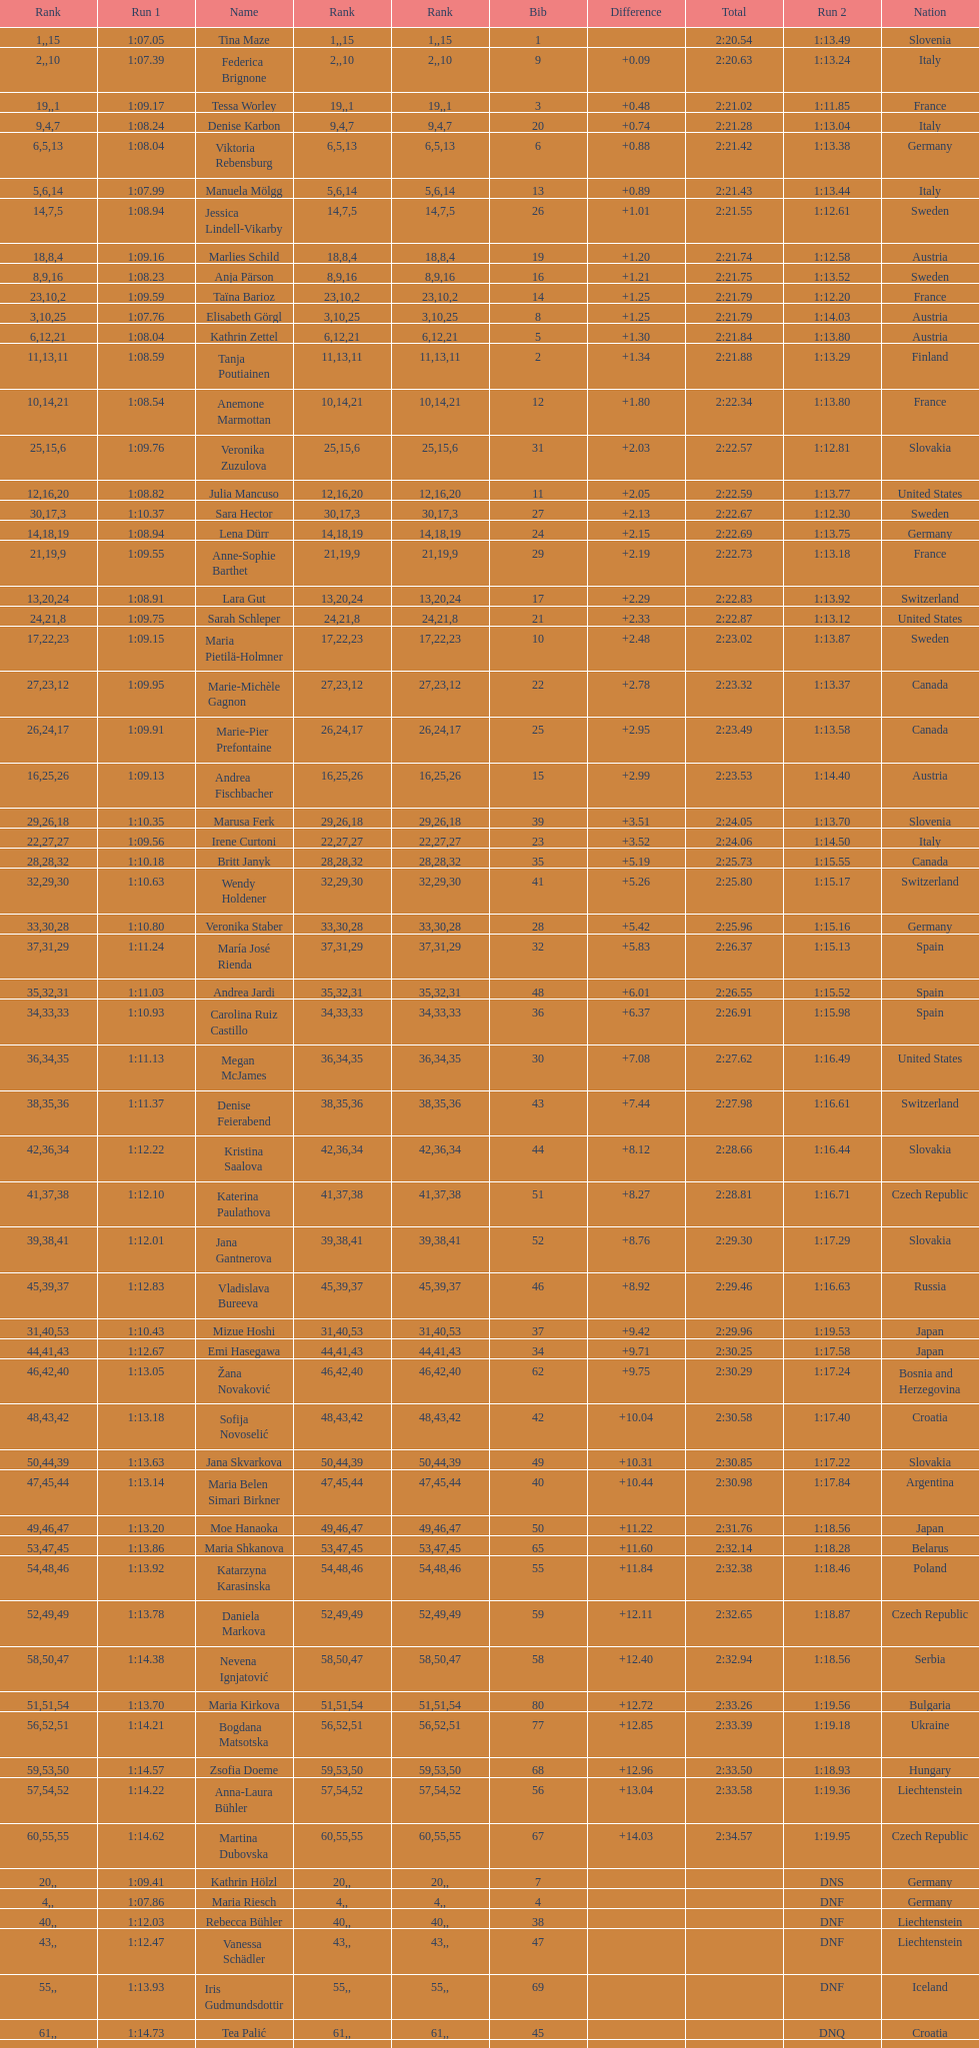How many athletes had the same rank for both run 1 and run 2? 1. 